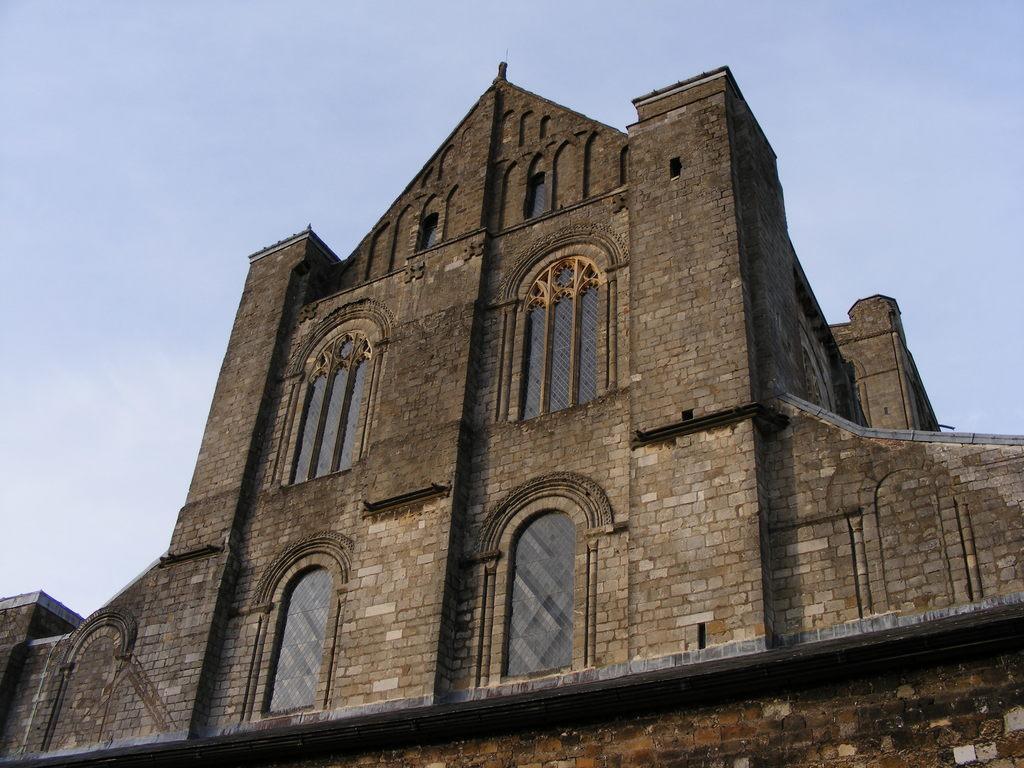Can you describe this image briefly? In this image I can see the building with windows. In the background I can see the sky. 